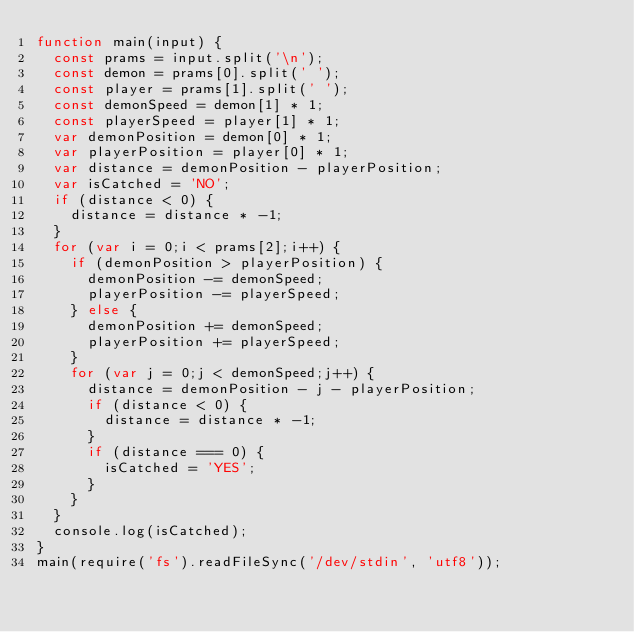<code> <loc_0><loc_0><loc_500><loc_500><_JavaScript_>function main(input) {
  const prams = input.split('\n');
  const demon = prams[0].split(' ');
  const player = prams[1].split(' ');
  const demonSpeed = demon[1] * 1;
  const playerSpeed = player[1] * 1;
  var demonPosition = demon[0] * 1;
  var playerPosition = player[0] * 1;
  var distance = demonPosition - playerPosition;
  var isCatched = 'NO';
  if (distance < 0) {
    distance = distance * -1;
  }
  for (var i = 0;i < prams[2];i++) {
    if (demonPosition > playerPosition) {
      demonPosition -= demonSpeed;
      playerPosition -= playerSpeed;
    } else {
      demonPosition += demonSpeed;
      playerPosition += playerSpeed;
    }
    for (var j = 0;j < demonSpeed;j++) {
      distance = demonPosition - j - playerPosition;
      if (distance < 0) {
        distance = distance * -1;
      }
      if (distance === 0) {
        isCatched = 'YES';
      }
    }
  }
  console.log(isCatched);
}
main(require('fs').readFileSync('/dev/stdin', 'utf8'));</code> 